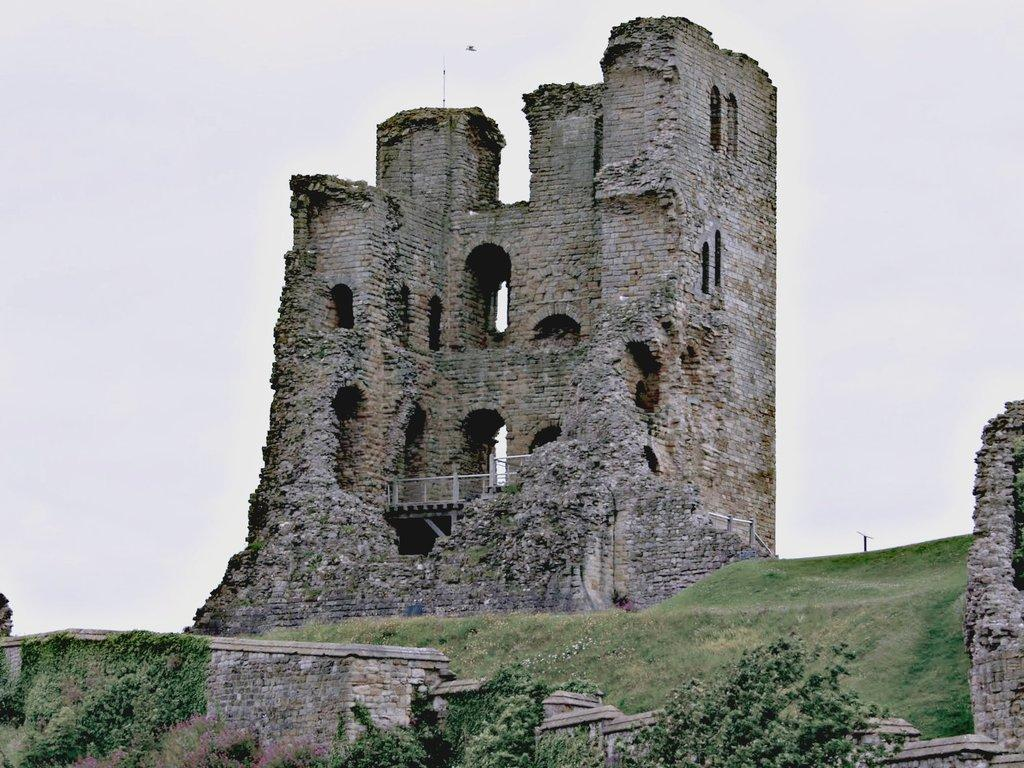What type of structure is present in the image? There is a fort in the image. What type of vegetation is visible in front of the fort? There is grass in front of the fort. What other natural elements can be seen in the image? There are trees in the image. What type of advice can be seen written on the fort in the image? There is no advice visible on the fort in the image; it is a structure and not a source of advice. 